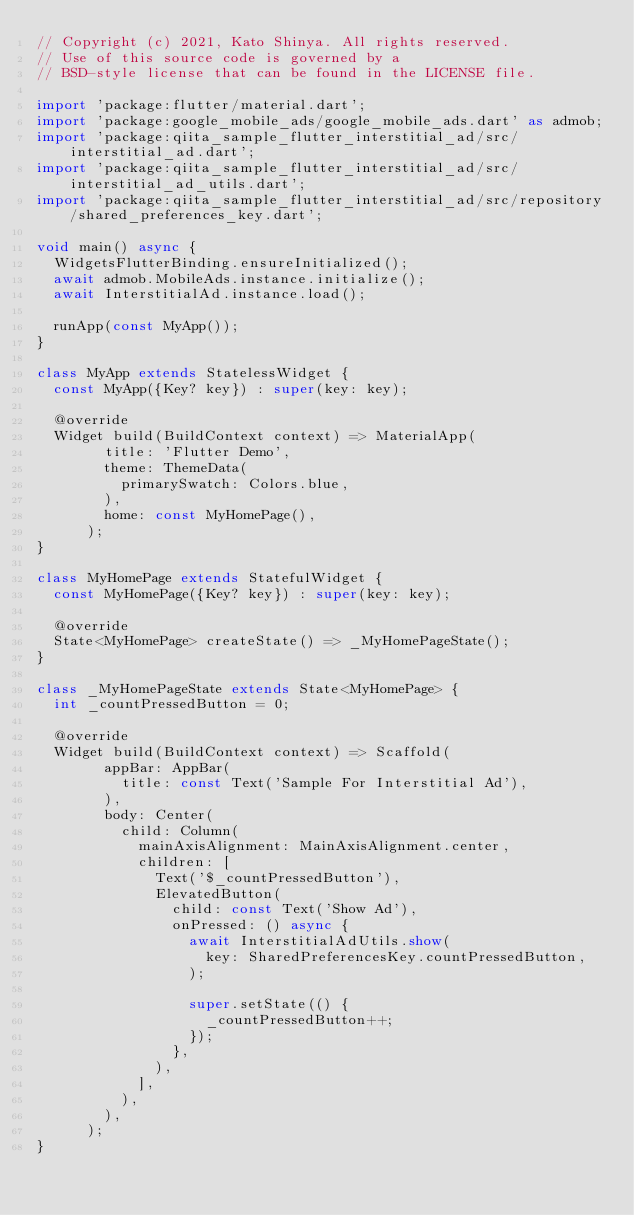<code> <loc_0><loc_0><loc_500><loc_500><_Dart_>// Copyright (c) 2021, Kato Shinya. All rights reserved.
// Use of this source code is governed by a
// BSD-style license that can be found in the LICENSE file.

import 'package:flutter/material.dart';
import 'package:google_mobile_ads/google_mobile_ads.dart' as admob;
import 'package:qiita_sample_flutter_interstitial_ad/src/interstitial_ad.dart';
import 'package:qiita_sample_flutter_interstitial_ad/src/interstitial_ad_utils.dart';
import 'package:qiita_sample_flutter_interstitial_ad/src/repository/shared_preferences_key.dart';

void main() async {
  WidgetsFlutterBinding.ensureInitialized();
  await admob.MobileAds.instance.initialize();
  await InterstitialAd.instance.load();

  runApp(const MyApp());
}

class MyApp extends StatelessWidget {
  const MyApp({Key? key}) : super(key: key);

  @override
  Widget build(BuildContext context) => MaterialApp(
        title: 'Flutter Demo',
        theme: ThemeData(
          primarySwatch: Colors.blue,
        ),
        home: const MyHomePage(),
      );
}

class MyHomePage extends StatefulWidget {
  const MyHomePage({Key? key}) : super(key: key);

  @override
  State<MyHomePage> createState() => _MyHomePageState();
}

class _MyHomePageState extends State<MyHomePage> {
  int _countPressedButton = 0;

  @override
  Widget build(BuildContext context) => Scaffold(
        appBar: AppBar(
          title: const Text('Sample For Interstitial Ad'),
        ),
        body: Center(
          child: Column(
            mainAxisAlignment: MainAxisAlignment.center,
            children: [
              Text('$_countPressedButton'),
              ElevatedButton(
                child: const Text('Show Ad'),
                onPressed: () async {
                  await InterstitialAdUtils.show(
                    key: SharedPreferencesKey.countPressedButton,
                  );

                  super.setState(() {
                    _countPressedButton++;
                  });
                },
              ),
            ],
          ),
        ),
      );
}
</code> 